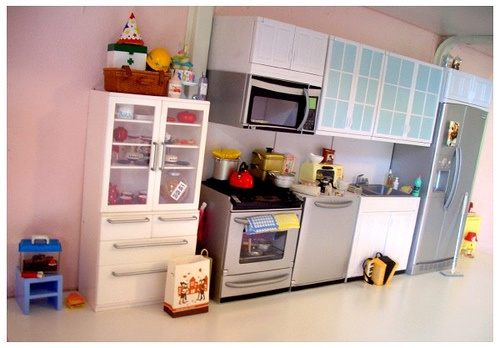Describe the objects in this image and their specific colors. I can see oven in white, black, darkgray, and gray tones, refrigerator in white, darkgray, gray, and lightgray tones, microwave in white, gray, black, and darkgray tones, sink in white and gray tones, and cup in white, darkgray, lightgray, and gray tones in this image. 